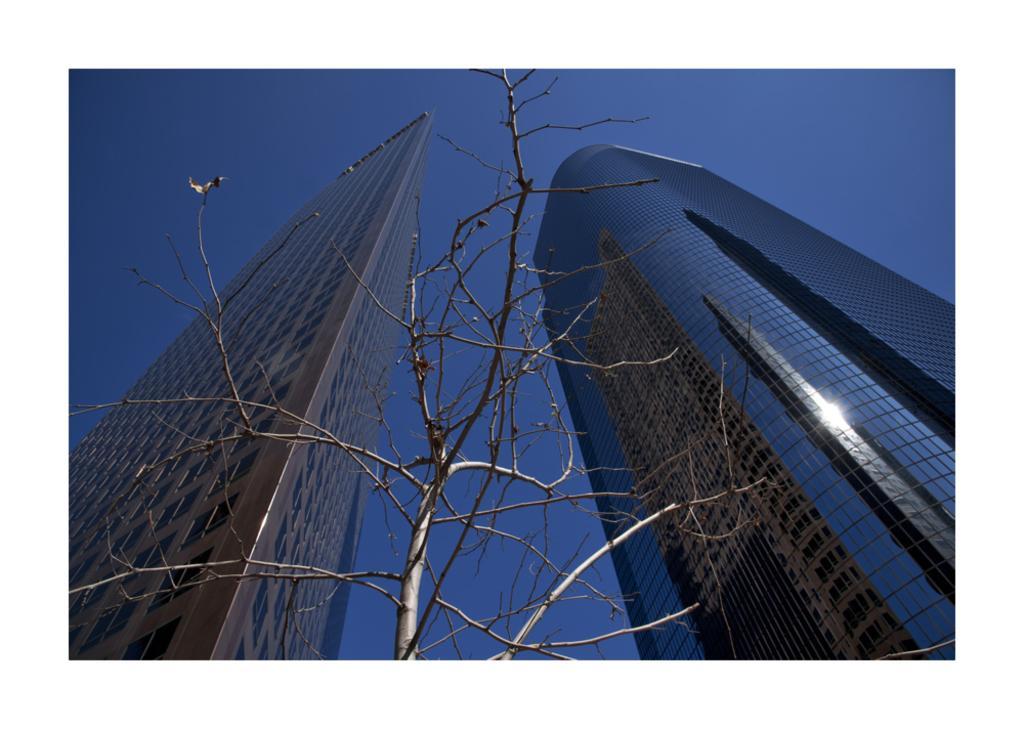Could you give a brief overview of what you see in this image? In this image we can see tree which has no leaves and there are some tallest buildings and top of the image there is clear sky. 